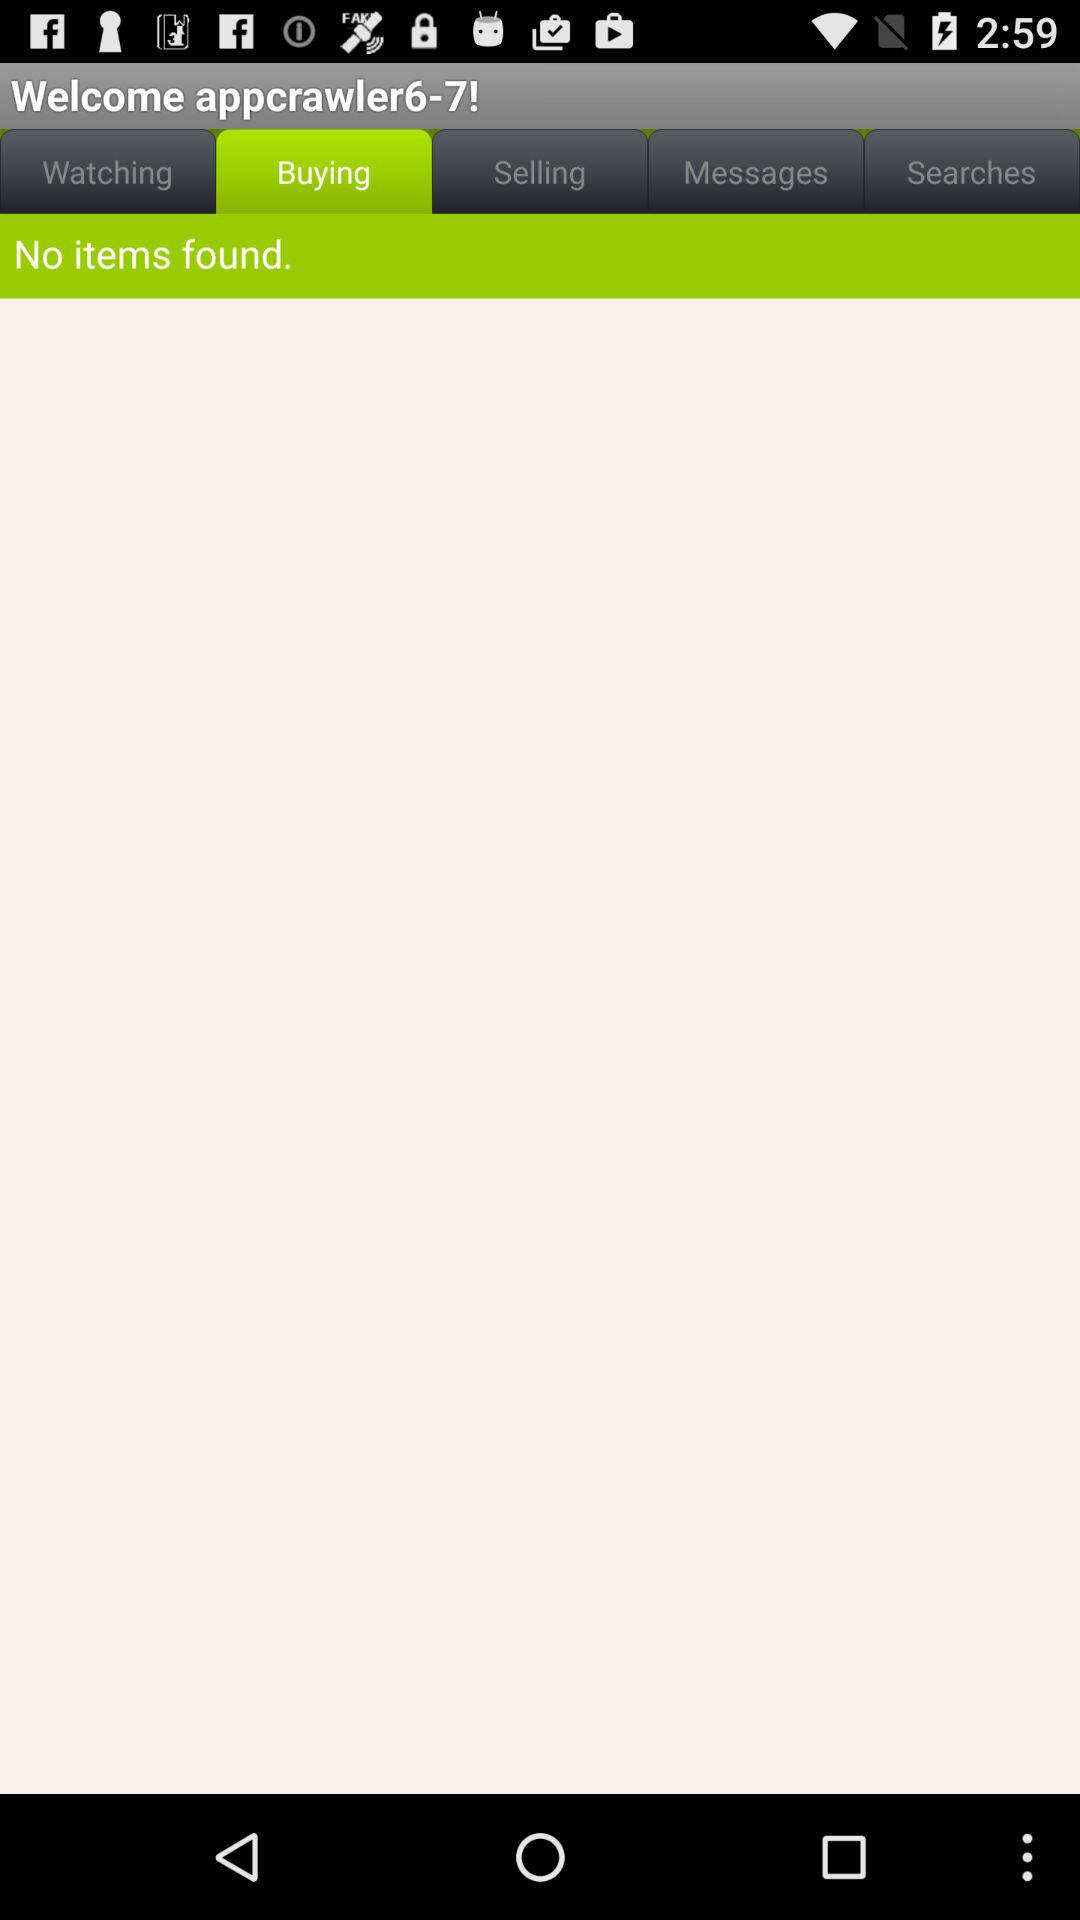What is the username? The username is "appcrawler6-7". 